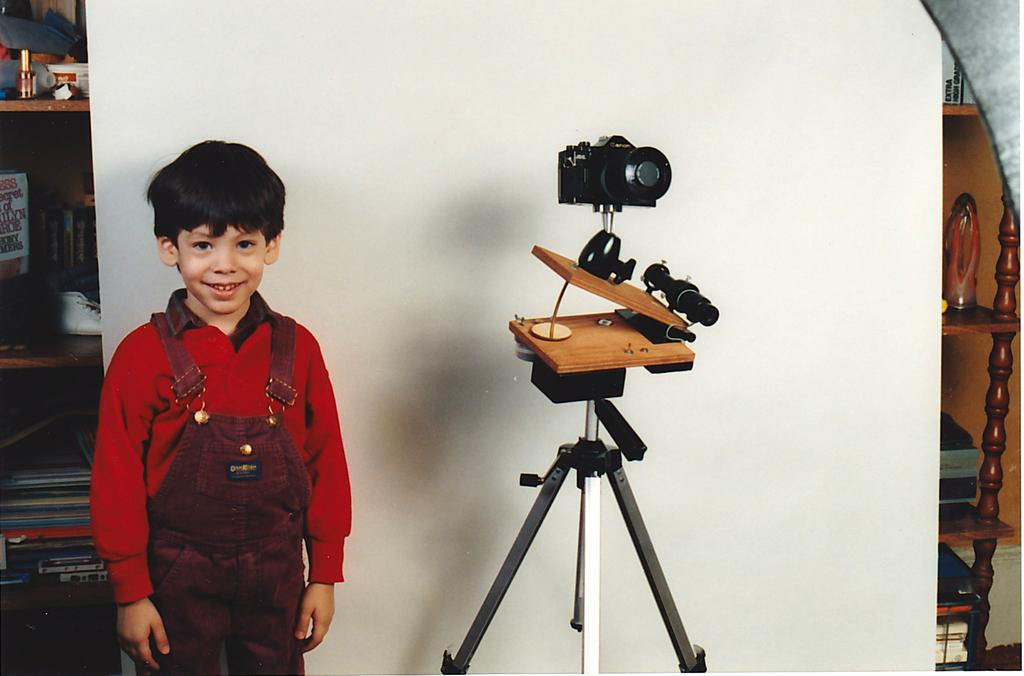What is the main subject of the image? The main subject of the image is a kid. Where is the kid located in the image? The kid is standing beside a stand. What is on the stand in the image? There is a camera on the stand. What type of furniture is present in the image? There are shelves in the image. What can be seen on the shelves? There are items placed on the shelves. What type of instrument is the kid playing in the image? There is no instrument present in the image, and the kid is not playing any instrument. Is there a bomb visible in the image? No, there is no bomb present in the image. 